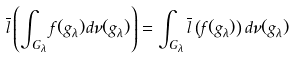Convert formula to latex. <formula><loc_0><loc_0><loc_500><loc_500>\overline { l } \left ( \int _ { G _ { \lambda } } f ( g _ { \lambda } ) d \nu ( g _ { \lambda } ) \right ) = \int _ { G _ { \lambda } } \overline { l } \left ( f ( g _ { \lambda } ) \right ) d \nu ( g _ { \lambda } )</formula> 